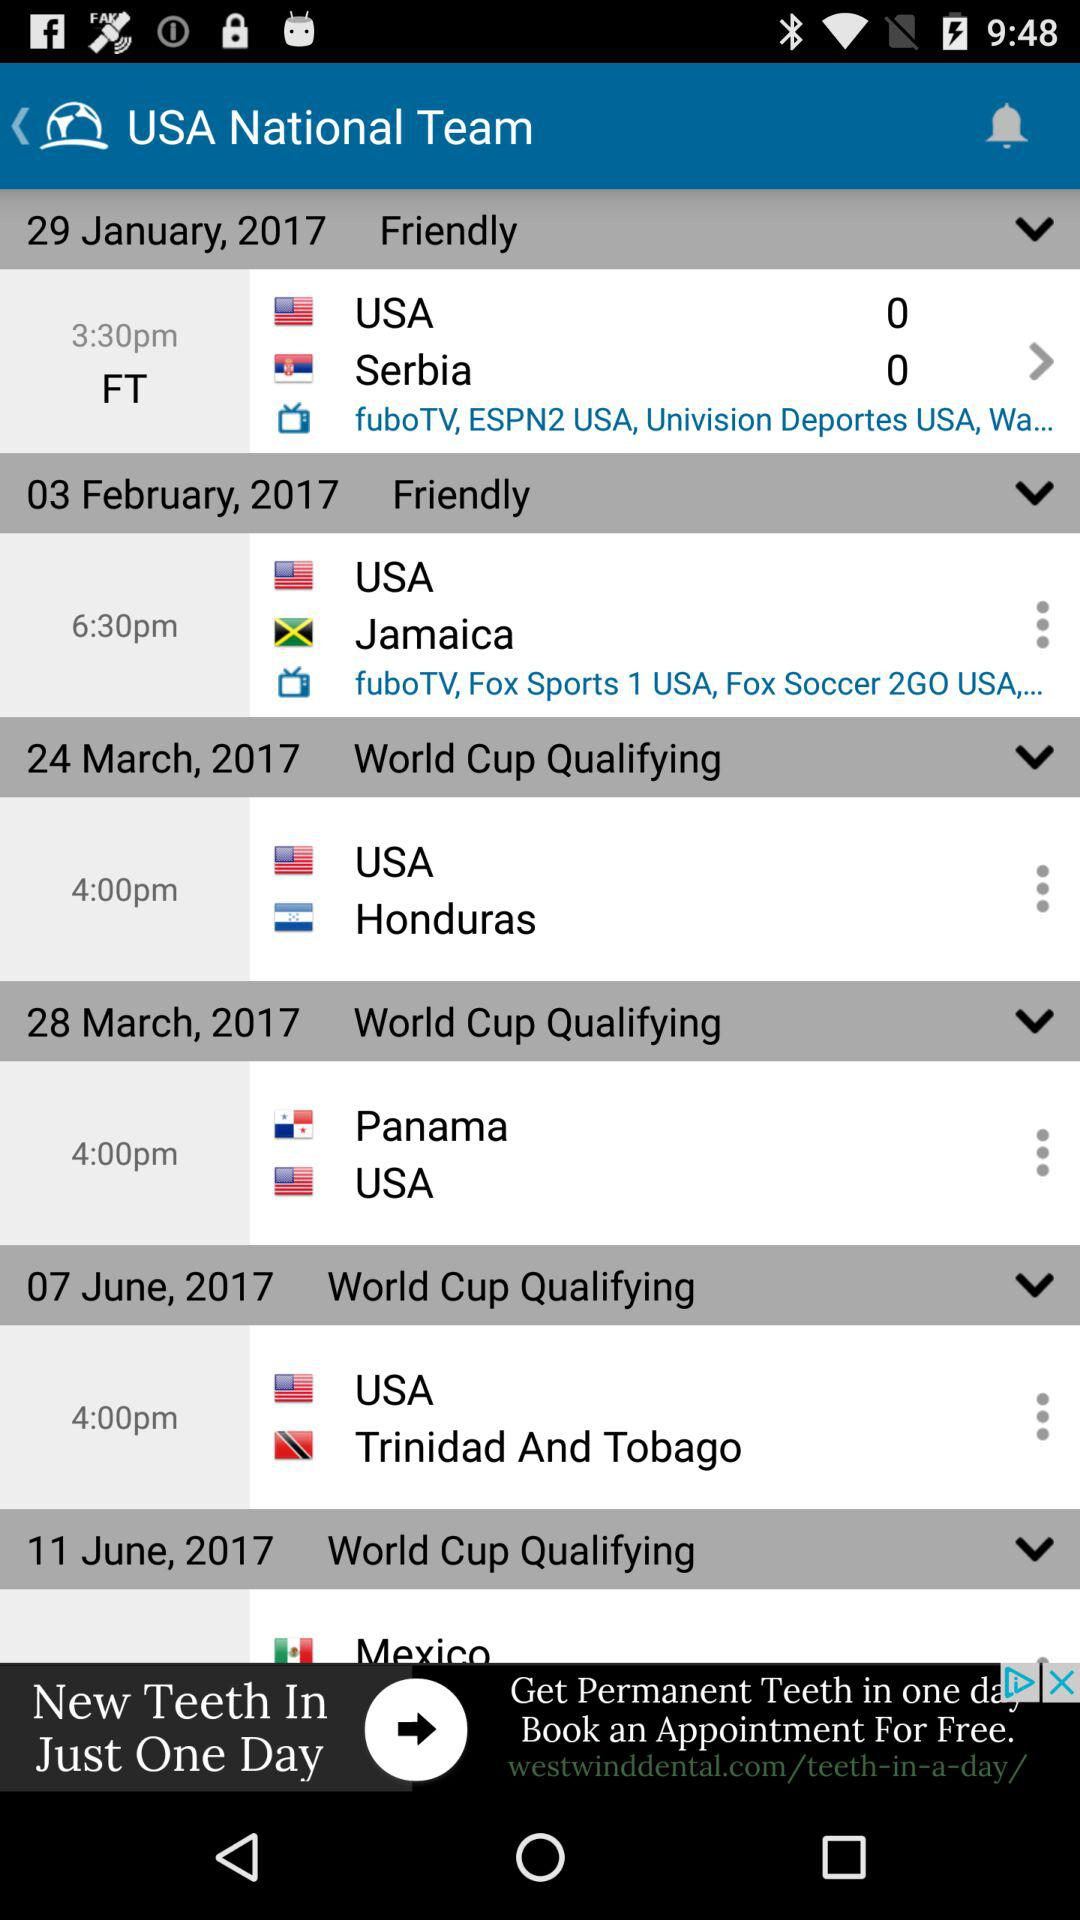On what date will the match between the USA and Serbia be held? The match will be held on January 29, 2017. 